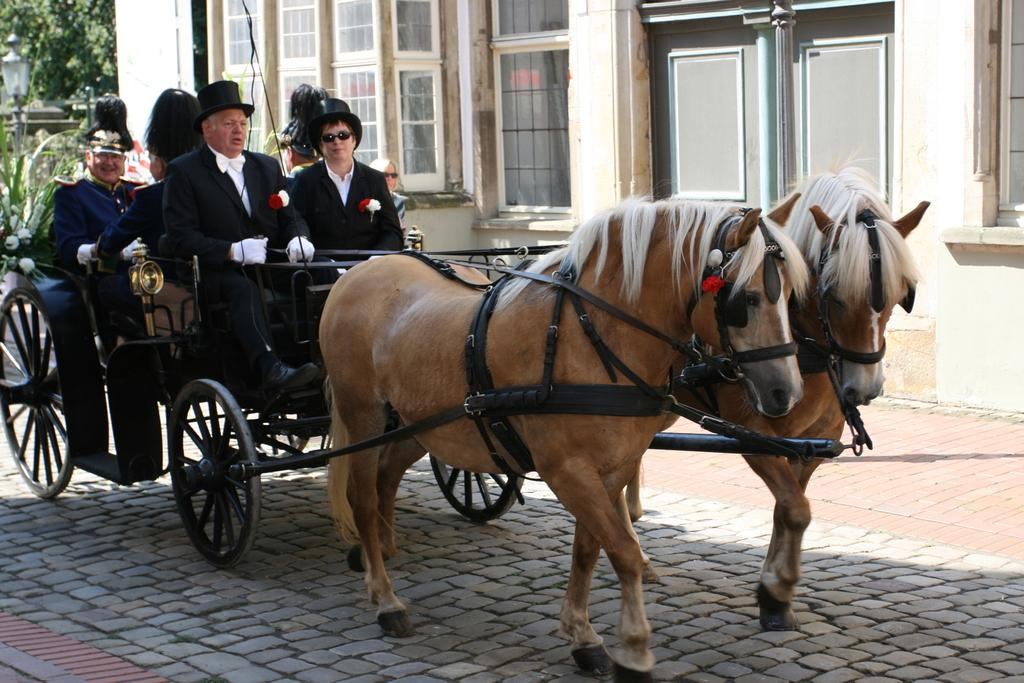What is the main subject of the image? The main subject of the image is a horse cart. What is the horse cart doing in the image? The horse cart is moving on a road. Who is in the horse cart? There are people sitting in the horse cart. What can be seen in the background of the image? There is a building and trees in the background of the image. How many mice are running around the wheels of the horse cart in the image? There are no mice present in the image, so it is not possible to determine how many might be running around the wheels. 